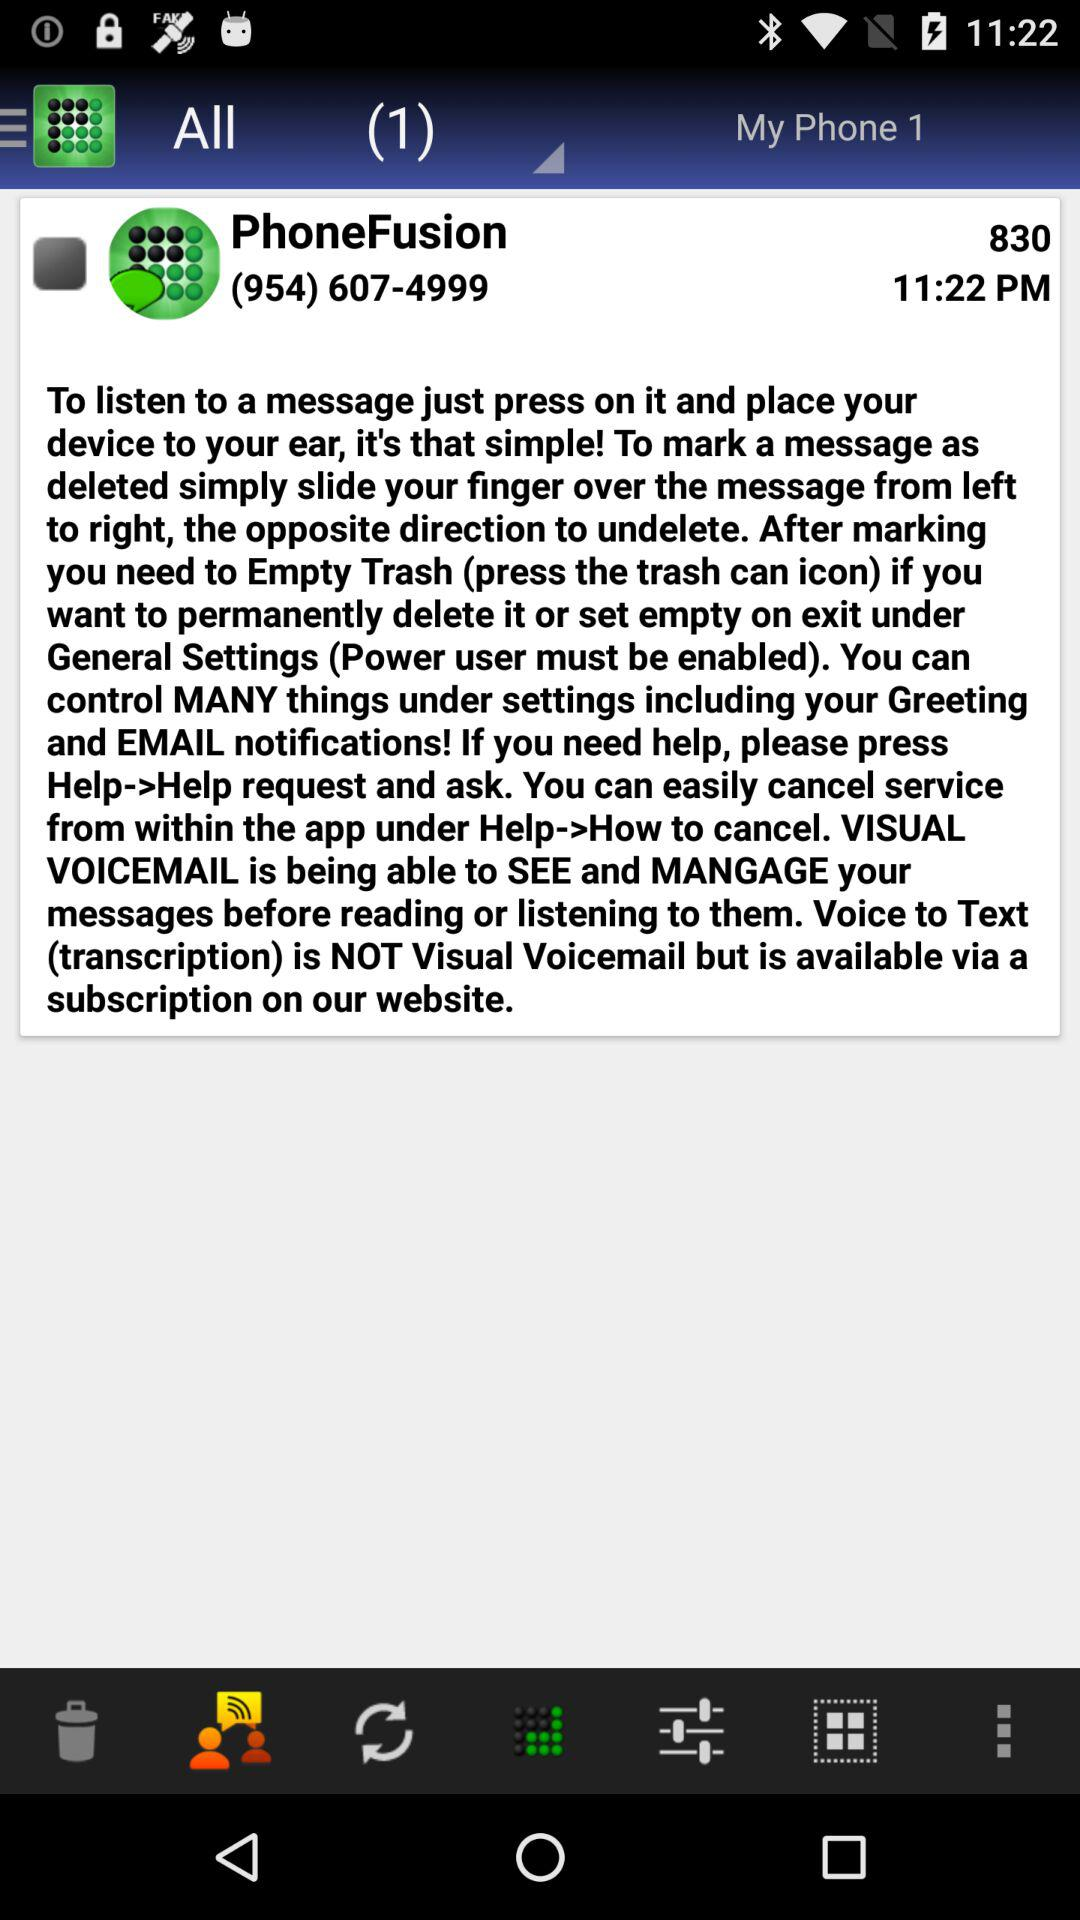What is the contact email for "PhoneFushion"?
When the provided information is insufficient, respond with <no answer>. <no answer> 